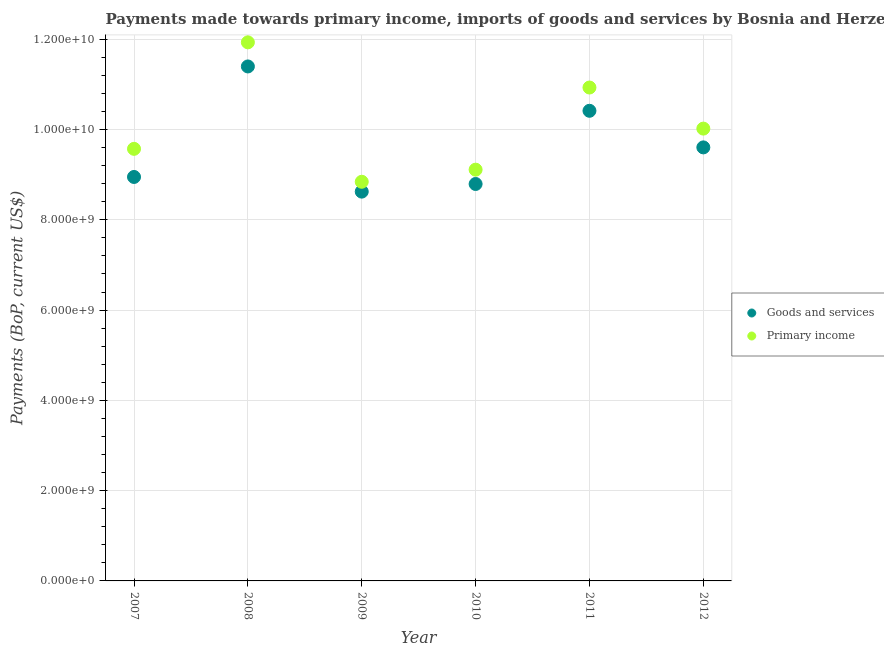Is the number of dotlines equal to the number of legend labels?
Your answer should be very brief. Yes. What is the payments made towards primary income in 2011?
Make the answer very short. 1.09e+1. Across all years, what is the maximum payments made towards goods and services?
Make the answer very short. 1.14e+1. Across all years, what is the minimum payments made towards primary income?
Make the answer very short. 8.84e+09. In which year was the payments made towards primary income maximum?
Offer a terse response. 2008. In which year was the payments made towards goods and services minimum?
Your answer should be compact. 2009. What is the total payments made towards primary income in the graph?
Your response must be concise. 6.04e+1. What is the difference between the payments made towards goods and services in 2010 and that in 2012?
Your response must be concise. -8.11e+08. What is the difference between the payments made towards primary income in 2007 and the payments made towards goods and services in 2008?
Provide a succinct answer. -1.83e+09. What is the average payments made towards goods and services per year?
Provide a short and direct response. 9.63e+09. In the year 2007, what is the difference between the payments made towards goods and services and payments made towards primary income?
Offer a very short reply. -6.23e+08. What is the ratio of the payments made towards primary income in 2008 to that in 2011?
Your answer should be compact. 1.09. Is the payments made towards primary income in 2010 less than that in 2011?
Offer a very short reply. Yes. Is the difference between the payments made towards goods and services in 2009 and 2010 greater than the difference between the payments made towards primary income in 2009 and 2010?
Give a very brief answer. Yes. What is the difference between the highest and the second highest payments made towards goods and services?
Your response must be concise. 9.82e+08. What is the difference between the highest and the lowest payments made towards goods and services?
Provide a succinct answer. 2.77e+09. In how many years, is the payments made towards primary income greater than the average payments made towards primary income taken over all years?
Keep it short and to the point. 2. Is the sum of the payments made towards primary income in 2009 and 2012 greater than the maximum payments made towards goods and services across all years?
Provide a short and direct response. Yes. What is the difference between two consecutive major ticks on the Y-axis?
Make the answer very short. 2.00e+09. How are the legend labels stacked?
Give a very brief answer. Vertical. What is the title of the graph?
Offer a terse response. Payments made towards primary income, imports of goods and services by Bosnia and Herzegovina. Does "Food" appear as one of the legend labels in the graph?
Make the answer very short. No. What is the label or title of the Y-axis?
Give a very brief answer. Payments (BoP, current US$). What is the Payments (BoP, current US$) of Goods and services in 2007?
Your answer should be very brief. 8.95e+09. What is the Payments (BoP, current US$) of Primary income in 2007?
Provide a short and direct response. 9.57e+09. What is the Payments (BoP, current US$) of Goods and services in 2008?
Keep it short and to the point. 1.14e+1. What is the Payments (BoP, current US$) in Primary income in 2008?
Offer a terse response. 1.19e+1. What is the Payments (BoP, current US$) in Goods and services in 2009?
Keep it short and to the point. 8.62e+09. What is the Payments (BoP, current US$) in Primary income in 2009?
Offer a terse response. 8.84e+09. What is the Payments (BoP, current US$) of Goods and services in 2010?
Make the answer very short. 8.79e+09. What is the Payments (BoP, current US$) of Primary income in 2010?
Keep it short and to the point. 9.11e+09. What is the Payments (BoP, current US$) in Goods and services in 2011?
Offer a very short reply. 1.04e+1. What is the Payments (BoP, current US$) of Primary income in 2011?
Ensure brevity in your answer.  1.09e+1. What is the Payments (BoP, current US$) in Goods and services in 2012?
Give a very brief answer. 9.60e+09. What is the Payments (BoP, current US$) in Primary income in 2012?
Give a very brief answer. 1.00e+1. Across all years, what is the maximum Payments (BoP, current US$) of Goods and services?
Offer a very short reply. 1.14e+1. Across all years, what is the maximum Payments (BoP, current US$) of Primary income?
Your response must be concise. 1.19e+1. Across all years, what is the minimum Payments (BoP, current US$) in Goods and services?
Offer a very short reply. 8.62e+09. Across all years, what is the minimum Payments (BoP, current US$) in Primary income?
Keep it short and to the point. 8.84e+09. What is the total Payments (BoP, current US$) in Goods and services in the graph?
Provide a succinct answer. 5.78e+1. What is the total Payments (BoP, current US$) in Primary income in the graph?
Give a very brief answer. 6.04e+1. What is the difference between the Payments (BoP, current US$) of Goods and services in 2007 and that in 2008?
Provide a succinct answer. -2.45e+09. What is the difference between the Payments (BoP, current US$) in Primary income in 2007 and that in 2008?
Your response must be concise. -2.36e+09. What is the difference between the Payments (BoP, current US$) of Goods and services in 2007 and that in 2009?
Offer a very short reply. 3.25e+08. What is the difference between the Payments (BoP, current US$) of Primary income in 2007 and that in 2009?
Offer a terse response. 7.30e+08. What is the difference between the Payments (BoP, current US$) of Goods and services in 2007 and that in 2010?
Give a very brief answer. 1.56e+08. What is the difference between the Payments (BoP, current US$) in Primary income in 2007 and that in 2010?
Provide a succinct answer. 4.62e+08. What is the difference between the Payments (BoP, current US$) in Goods and services in 2007 and that in 2011?
Provide a succinct answer. -1.47e+09. What is the difference between the Payments (BoP, current US$) in Primary income in 2007 and that in 2011?
Offer a very short reply. -1.36e+09. What is the difference between the Payments (BoP, current US$) in Goods and services in 2007 and that in 2012?
Your answer should be very brief. -6.55e+08. What is the difference between the Payments (BoP, current US$) of Primary income in 2007 and that in 2012?
Your answer should be very brief. -4.48e+08. What is the difference between the Payments (BoP, current US$) of Goods and services in 2008 and that in 2009?
Provide a succinct answer. 2.77e+09. What is the difference between the Payments (BoP, current US$) in Primary income in 2008 and that in 2009?
Offer a terse response. 3.09e+09. What is the difference between the Payments (BoP, current US$) of Goods and services in 2008 and that in 2010?
Your response must be concise. 2.60e+09. What is the difference between the Payments (BoP, current US$) in Primary income in 2008 and that in 2010?
Your answer should be very brief. 2.82e+09. What is the difference between the Payments (BoP, current US$) of Goods and services in 2008 and that in 2011?
Your response must be concise. 9.82e+08. What is the difference between the Payments (BoP, current US$) in Primary income in 2008 and that in 2011?
Give a very brief answer. 1.00e+09. What is the difference between the Payments (BoP, current US$) in Goods and services in 2008 and that in 2012?
Give a very brief answer. 1.79e+09. What is the difference between the Payments (BoP, current US$) of Primary income in 2008 and that in 2012?
Provide a succinct answer. 1.91e+09. What is the difference between the Payments (BoP, current US$) of Goods and services in 2009 and that in 2010?
Keep it short and to the point. -1.69e+08. What is the difference between the Payments (BoP, current US$) of Primary income in 2009 and that in 2010?
Offer a terse response. -2.68e+08. What is the difference between the Payments (BoP, current US$) in Goods and services in 2009 and that in 2011?
Make the answer very short. -1.79e+09. What is the difference between the Payments (BoP, current US$) in Primary income in 2009 and that in 2011?
Keep it short and to the point. -2.09e+09. What is the difference between the Payments (BoP, current US$) in Goods and services in 2009 and that in 2012?
Your answer should be very brief. -9.80e+08. What is the difference between the Payments (BoP, current US$) in Primary income in 2009 and that in 2012?
Give a very brief answer. -1.18e+09. What is the difference between the Payments (BoP, current US$) in Goods and services in 2010 and that in 2011?
Keep it short and to the point. -1.62e+09. What is the difference between the Payments (BoP, current US$) in Primary income in 2010 and that in 2011?
Your answer should be very brief. -1.82e+09. What is the difference between the Payments (BoP, current US$) of Goods and services in 2010 and that in 2012?
Offer a very short reply. -8.11e+08. What is the difference between the Payments (BoP, current US$) in Primary income in 2010 and that in 2012?
Make the answer very short. -9.10e+08. What is the difference between the Payments (BoP, current US$) of Goods and services in 2011 and that in 2012?
Give a very brief answer. 8.11e+08. What is the difference between the Payments (BoP, current US$) in Primary income in 2011 and that in 2012?
Ensure brevity in your answer.  9.10e+08. What is the difference between the Payments (BoP, current US$) of Goods and services in 2007 and the Payments (BoP, current US$) of Primary income in 2008?
Provide a short and direct response. -2.98e+09. What is the difference between the Payments (BoP, current US$) in Goods and services in 2007 and the Payments (BoP, current US$) in Primary income in 2009?
Keep it short and to the point. 1.07e+08. What is the difference between the Payments (BoP, current US$) of Goods and services in 2007 and the Payments (BoP, current US$) of Primary income in 2010?
Offer a terse response. -1.62e+08. What is the difference between the Payments (BoP, current US$) of Goods and services in 2007 and the Payments (BoP, current US$) of Primary income in 2011?
Keep it short and to the point. -1.98e+09. What is the difference between the Payments (BoP, current US$) of Goods and services in 2007 and the Payments (BoP, current US$) of Primary income in 2012?
Provide a succinct answer. -1.07e+09. What is the difference between the Payments (BoP, current US$) in Goods and services in 2008 and the Payments (BoP, current US$) in Primary income in 2009?
Provide a short and direct response. 2.56e+09. What is the difference between the Payments (BoP, current US$) of Goods and services in 2008 and the Payments (BoP, current US$) of Primary income in 2010?
Your answer should be compact. 2.29e+09. What is the difference between the Payments (BoP, current US$) of Goods and services in 2008 and the Payments (BoP, current US$) of Primary income in 2011?
Ensure brevity in your answer.  4.67e+08. What is the difference between the Payments (BoP, current US$) of Goods and services in 2008 and the Payments (BoP, current US$) of Primary income in 2012?
Keep it short and to the point. 1.38e+09. What is the difference between the Payments (BoP, current US$) in Goods and services in 2009 and the Payments (BoP, current US$) in Primary income in 2010?
Your answer should be compact. -4.86e+08. What is the difference between the Payments (BoP, current US$) in Goods and services in 2009 and the Payments (BoP, current US$) in Primary income in 2011?
Your response must be concise. -2.31e+09. What is the difference between the Payments (BoP, current US$) in Goods and services in 2009 and the Payments (BoP, current US$) in Primary income in 2012?
Your response must be concise. -1.40e+09. What is the difference between the Payments (BoP, current US$) in Goods and services in 2010 and the Payments (BoP, current US$) in Primary income in 2011?
Your response must be concise. -2.14e+09. What is the difference between the Payments (BoP, current US$) of Goods and services in 2010 and the Payments (BoP, current US$) of Primary income in 2012?
Your answer should be very brief. -1.23e+09. What is the difference between the Payments (BoP, current US$) in Goods and services in 2011 and the Payments (BoP, current US$) in Primary income in 2012?
Your answer should be compact. 3.95e+08. What is the average Payments (BoP, current US$) in Goods and services per year?
Keep it short and to the point. 9.63e+09. What is the average Payments (BoP, current US$) of Primary income per year?
Offer a very short reply. 1.01e+1. In the year 2007, what is the difference between the Payments (BoP, current US$) in Goods and services and Payments (BoP, current US$) in Primary income?
Offer a terse response. -6.23e+08. In the year 2008, what is the difference between the Payments (BoP, current US$) of Goods and services and Payments (BoP, current US$) of Primary income?
Offer a very short reply. -5.34e+08. In the year 2009, what is the difference between the Payments (BoP, current US$) in Goods and services and Payments (BoP, current US$) in Primary income?
Provide a short and direct response. -2.18e+08. In the year 2010, what is the difference between the Payments (BoP, current US$) in Goods and services and Payments (BoP, current US$) in Primary income?
Offer a terse response. -3.17e+08. In the year 2011, what is the difference between the Payments (BoP, current US$) of Goods and services and Payments (BoP, current US$) of Primary income?
Offer a terse response. -5.16e+08. In the year 2012, what is the difference between the Payments (BoP, current US$) in Goods and services and Payments (BoP, current US$) in Primary income?
Offer a terse response. -4.16e+08. What is the ratio of the Payments (BoP, current US$) in Goods and services in 2007 to that in 2008?
Make the answer very short. 0.79. What is the ratio of the Payments (BoP, current US$) in Primary income in 2007 to that in 2008?
Offer a very short reply. 0.8. What is the ratio of the Payments (BoP, current US$) of Goods and services in 2007 to that in 2009?
Provide a succinct answer. 1.04. What is the ratio of the Payments (BoP, current US$) in Primary income in 2007 to that in 2009?
Offer a terse response. 1.08. What is the ratio of the Payments (BoP, current US$) in Goods and services in 2007 to that in 2010?
Provide a succinct answer. 1.02. What is the ratio of the Payments (BoP, current US$) of Primary income in 2007 to that in 2010?
Ensure brevity in your answer.  1.05. What is the ratio of the Payments (BoP, current US$) of Goods and services in 2007 to that in 2011?
Your answer should be very brief. 0.86. What is the ratio of the Payments (BoP, current US$) of Primary income in 2007 to that in 2011?
Offer a very short reply. 0.88. What is the ratio of the Payments (BoP, current US$) of Goods and services in 2007 to that in 2012?
Your response must be concise. 0.93. What is the ratio of the Payments (BoP, current US$) of Primary income in 2007 to that in 2012?
Your answer should be very brief. 0.96. What is the ratio of the Payments (BoP, current US$) of Goods and services in 2008 to that in 2009?
Your answer should be very brief. 1.32. What is the ratio of the Payments (BoP, current US$) of Primary income in 2008 to that in 2009?
Provide a succinct answer. 1.35. What is the ratio of the Payments (BoP, current US$) of Goods and services in 2008 to that in 2010?
Keep it short and to the point. 1.3. What is the ratio of the Payments (BoP, current US$) of Primary income in 2008 to that in 2010?
Ensure brevity in your answer.  1.31. What is the ratio of the Payments (BoP, current US$) in Goods and services in 2008 to that in 2011?
Offer a very short reply. 1.09. What is the ratio of the Payments (BoP, current US$) in Primary income in 2008 to that in 2011?
Your answer should be very brief. 1.09. What is the ratio of the Payments (BoP, current US$) in Goods and services in 2008 to that in 2012?
Provide a short and direct response. 1.19. What is the ratio of the Payments (BoP, current US$) of Primary income in 2008 to that in 2012?
Provide a short and direct response. 1.19. What is the ratio of the Payments (BoP, current US$) of Goods and services in 2009 to that in 2010?
Provide a short and direct response. 0.98. What is the ratio of the Payments (BoP, current US$) of Primary income in 2009 to that in 2010?
Offer a terse response. 0.97. What is the ratio of the Payments (BoP, current US$) of Goods and services in 2009 to that in 2011?
Make the answer very short. 0.83. What is the ratio of the Payments (BoP, current US$) in Primary income in 2009 to that in 2011?
Offer a very short reply. 0.81. What is the ratio of the Payments (BoP, current US$) of Goods and services in 2009 to that in 2012?
Provide a succinct answer. 0.9. What is the ratio of the Payments (BoP, current US$) in Primary income in 2009 to that in 2012?
Offer a terse response. 0.88. What is the ratio of the Payments (BoP, current US$) of Goods and services in 2010 to that in 2011?
Offer a terse response. 0.84. What is the ratio of the Payments (BoP, current US$) of Primary income in 2010 to that in 2011?
Your answer should be very brief. 0.83. What is the ratio of the Payments (BoP, current US$) of Goods and services in 2010 to that in 2012?
Your answer should be compact. 0.92. What is the ratio of the Payments (BoP, current US$) in Primary income in 2010 to that in 2012?
Your answer should be very brief. 0.91. What is the ratio of the Payments (BoP, current US$) of Goods and services in 2011 to that in 2012?
Your response must be concise. 1.08. What is the ratio of the Payments (BoP, current US$) in Primary income in 2011 to that in 2012?
Keep it short and to the point. 1.09. What is the difference between the highest and the second highest Payments (BoP, current US$) in Goods and services?
Keep it short and to the point. 9.82e+08. What is the difference between the highest and the second highest Payments (BoP, current US$) in Primary income?
Ensure brevity in your answer.  1.00e+09. What is the difference between the highest and the lowest Payments (BoP, current US$) in Goods and services?
Offer a terse response. 2.77e+09. What is the difference between the highest and the lowest Payments (BoP, current US$) in Primary income?
Make the answer very short. 3.09e+09. 